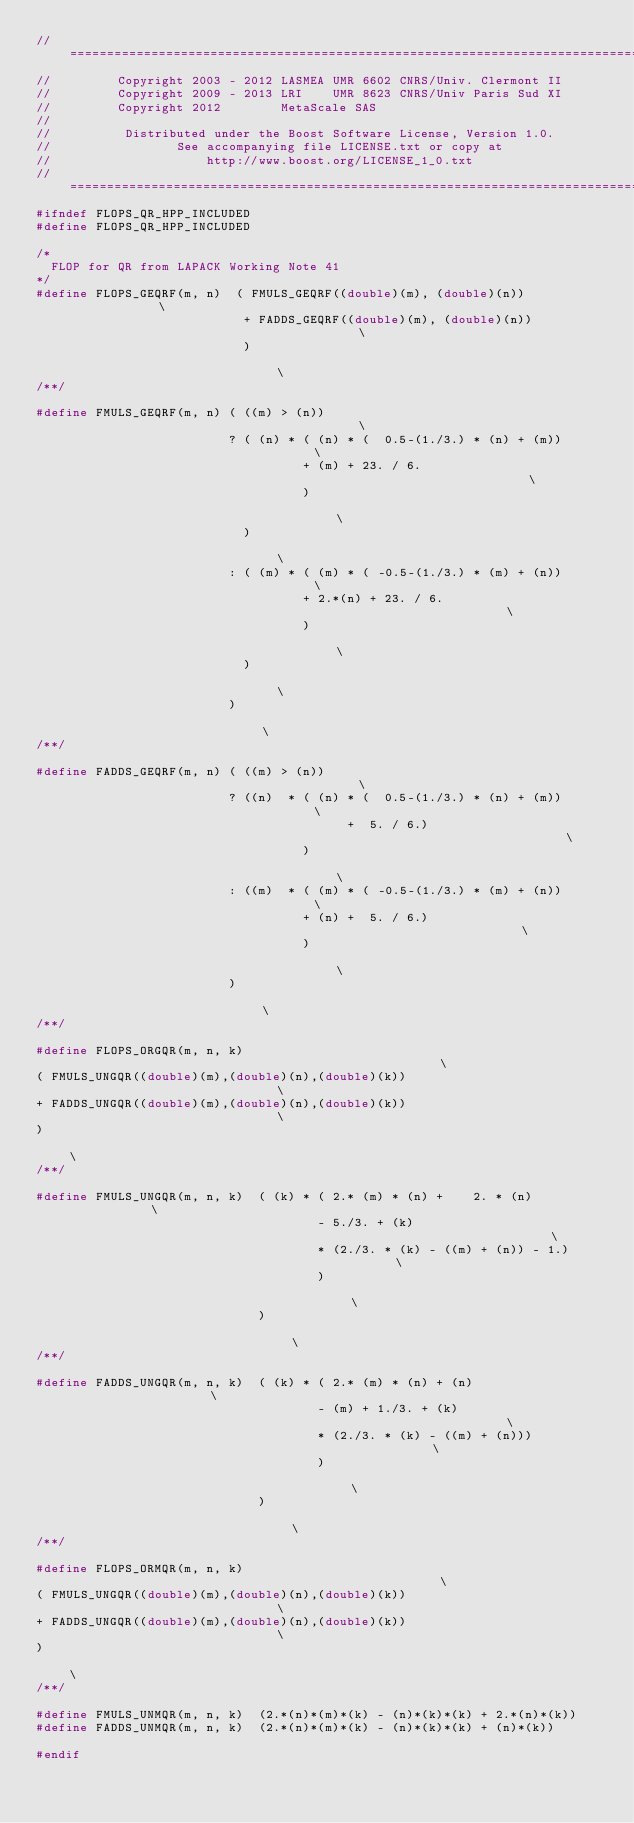Convert code to text. <code><loc_0><loc_0><loc_500><loc_500><_C++_>//==============================================================================
//         Copyright 2003 - 2012 LASMEA UMR 6602 CNRS/Univ. Clermont II
//         Copyright 2009 - 2013 LRI    UMR 8623 CNRS/Univ Paris Sud XI
//         Copyright 2012        MetaScale SAS
//
//          Distributed under the Boost Software License, Version 1.0.
//                 See accompanying file LICENSE.txt or copy at
//                     http://www.boost.org/LICENSE_1_0.txt
//==============================================================================
#ifndef FLOPS_QR_HPP_INCLUDED
#define FLOPS_QR_HPP_INCLUDED

/*
  FLOP for QR from LAPACK Working Note 41
*/
#define FLOPS_GEQRF(m, n)  ( FMULS_GEQRF((double)(m), (double)(n))             \
                            + FADDS_GEQRF((double)(m), (double)(n))            \
                            )                                                  \
/**/

#define FMULS_GEQRF(m, n) ( ((m) > (n))                                        \
                          ? ( (n) * ( (n) * (  0.5-(1./3.) * (n) + (m))        \
                                    + (m) + 23. / 6.                           \
                                    )                                          \
                            )                                                  \
                          : ( (m) * ( (m) * ( -0.5-(1./3.) * (m) + (n))        \
                                    + 2.*(n) + 23. / 6.                        \
                                    )                                          \
                            )                                                  \
                          )                                                    \
/**/

#define FADDS_GEQRF(m, n) ( ((m) > (n))                                        \
                          ? ((n)  * ( (n) * (  0.5-(1./3.) * (n) + (m))        \
                                          +  5. / 6.)                          \
                                    )                                          \
                          : ((m)  * ( (m) * ( -0.5-(1./3.) * (m) + (n))        \
                                    + (n) +  5. / 6.)                          \
                                    )                                          \
                          )                                                    \
/**/

#define FLOPS_ORGQR(m, n, k)                                                   \
( FMULS_UNGQR((double)(m),(double)(n),(double)(k))                             \
+ FADDS_UNGQR((double)(m),(double)(n),(double)(k))                             \
)                                                                              \
/**/

#define FMULS_UNGQR(m, n, k)  ( (k) * ( 2.* (m) * (n) +    2. * (n)            \
                                      - 5./3. + (k)                            \
                                      * (2./3. * (k) - ((m) + (n)) - 1.)       \
                                      )                                        \
                              )                                                \
/**/

#define FADDS_UNGQR(m, n, k)  ( (k) * ( 2.* (m) * (n) + (n)                    \
                                      - (m) + 1./3. + (k)                      \
                                      * (2./3. * (k) - ((m) + (n)))            \
                                      )                                        \
                              )                                                \
/**/

#define FLOPS_ORMQR(m, n, k)                                                   \
( FMULS_UNGQR((double)(m),(double)(n),(double)(k))                             \
+ FADDS_UNGQR((double)(m),(double)(n),(double)(k))                             \
)                                                                              \
/**/

#define FMULS_UNMQR(m, n, k)  (2.*(n)*(m)*(k) - (n)*(k)*(k) + 2.*(n)*(k))
#define FADDS_UNMQR(m, n, k)  (2.*(n)*(m)*(k) - (n)*(k)*(k) + (n)*(k))

#endif
</code> 